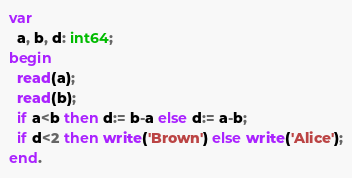<code> <loc_0><loc_0><loc_500><loc_500><_Pascal_>var
  a, b, d: int64;
begin
  read(a);
  read(b);
  if a<b then d:= b-a else d:= a-b;
  if d<2 then write('Brown') else write('Alice');
end.</code> 